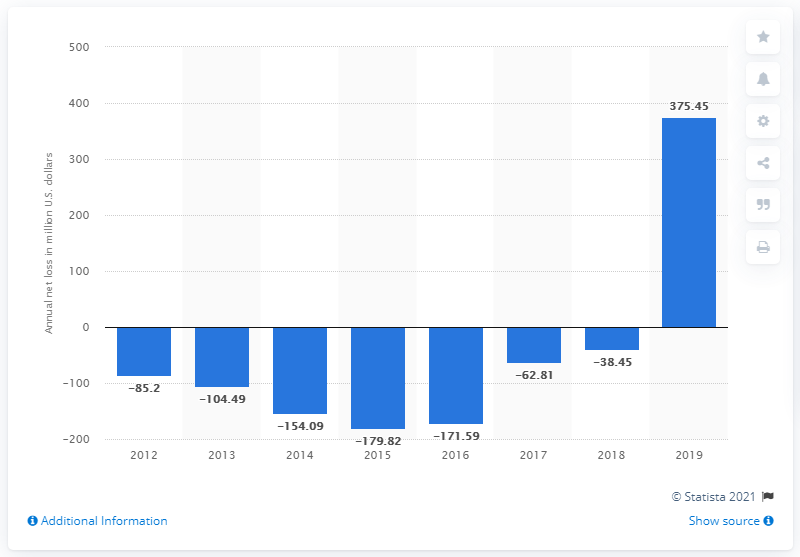Highlight a few significant elements in this photo. During the most recent fiscal period, Square's net income was $375.45 million. 